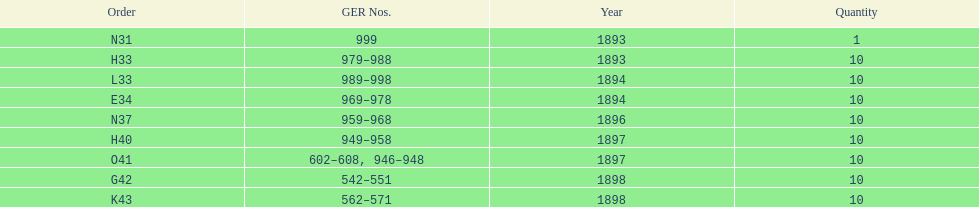Which had more ger numbers, 1898 or 1893? 1898. 